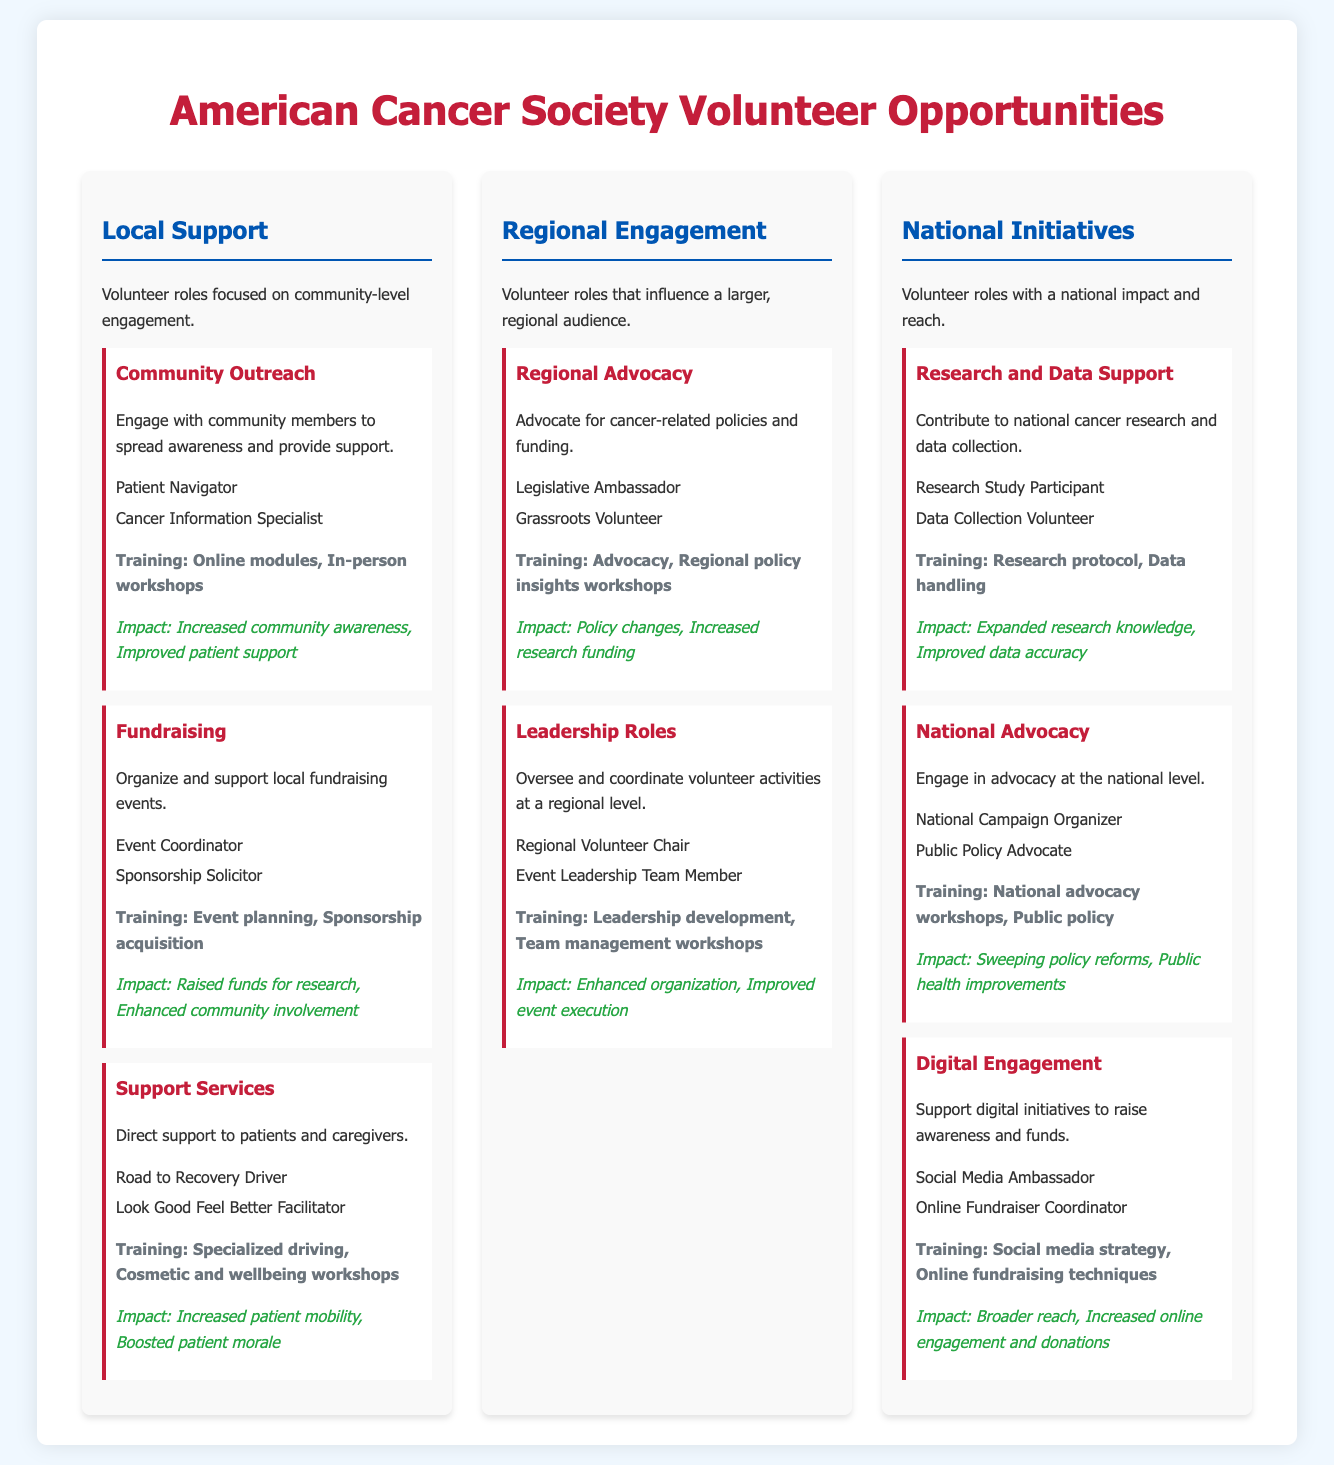What are the roles under Community Outreach? The document lists "Patient Navigator" and "Cancer Information Specialist" as roles under Community Outreach.
Answer: Patient Navigator, Cancer Information Specialist What training is required for Fundraising roles? The document states that Fundraising roles require training in "Event planning" and "Sponsorship acquisition."
Answer: Event planning, Sponsorship acquisition What is the impact area for Support Services? The document indicates that the impact area for Support Services includes "Increased patient mobility" and "Boosted patient morale."
Answer: Increased patient mobility, Boosted patient morale How many volunteer roles are listed under National Advocacy? The document lists two volunteer roles under National Advocacy: "National Campaign Organizer" and "Public Policy Advocate."
Answer: 2 What kind of training is required for Digital Engagement? The document states that training for Digital Engagement includes "Social media strategy" and "Online fundraising techniques."
Answer: Social media strategy, Online fundraising techniques Which branch focuses on community-level engagement? The document describes "Local Support" as the branch that focuses on community-level engagement.
Answer: Local Support What is the primary purpose of the National Initiatives branch? The document indicates that the National Initiatives branch covers volunteer roles with a national impact and reach.
Answer: National impact and reach What is one role listed under Regional Advocacy? The document specifies "Legislative Ambassador" as one of the roles listed under Regional Advocacy.
Answer: Legislative Ambassador 